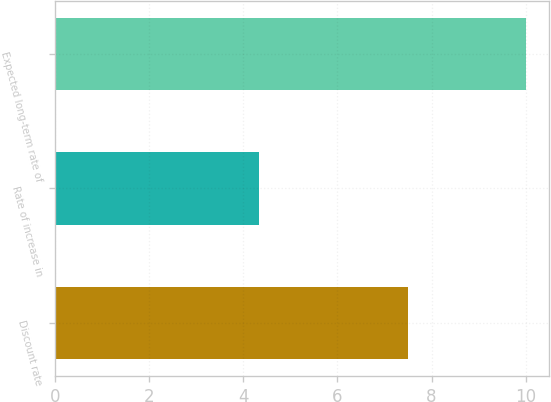Convert chart to OTSL. <chart><loc_0><loc_0><loc_500><loc_500><bar_chart><fcel>Discount rate<fcel>Rate of increase in<fcel>Expected long-term rate of<nl><fcel>7.5<fcel>4.33<fcel>10<nl></chart> 